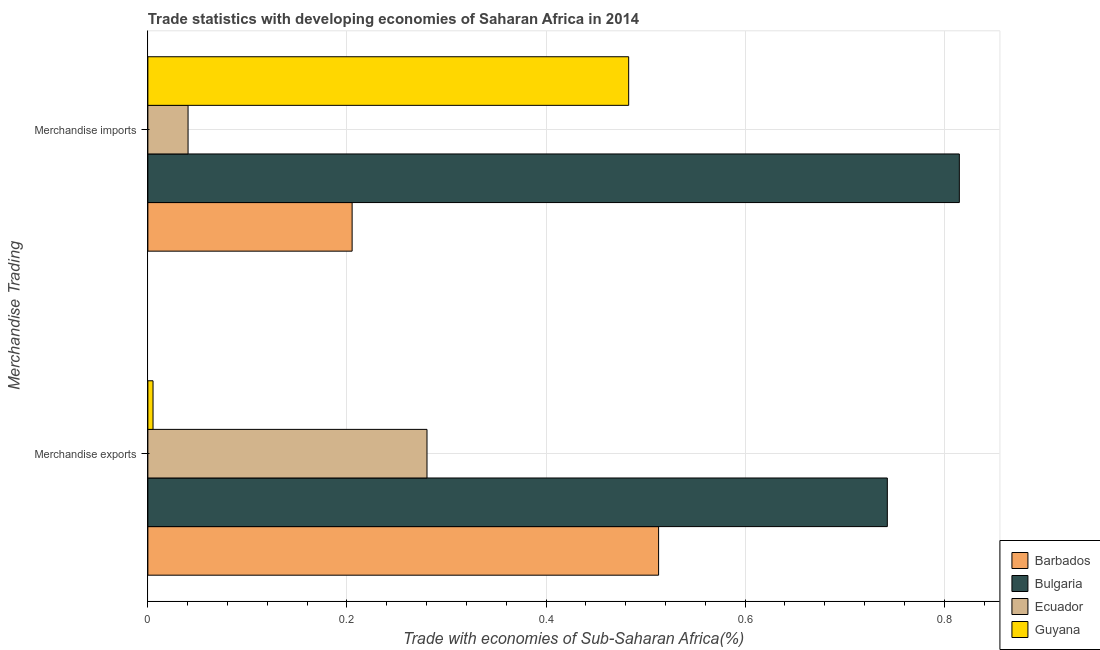What is the merchandise imports in Barbados?
Keep it short and to the point. 0.21. Across all countries, what is the maximum merchandise exports?
Your answer should be very brief. 0.74. Across all countries, what is the minimum merchandise exports?
Provide a succinct answer. 0.01. In which country was the merchandise imports maximum?
Offer a terse response. Bulgaria. In which country was the merchandise imports minimum?
Make the answer very short. Ecuador. What is the total merchandise imports in the graph?
Provide a succinct answer. 1.54. What is the difference between the merchandise exports in Barbados and that in Ecuador?
Provide a succinct answer. 0.23. What is the difference between the merchandise exports in Ecuador and the merchandise imports in Guyana?
Provide a succinct answer. -0.2. What is the average merchandise imports per country?
Keep it short and to the point. 0.39. What is the difference between the merchandise imports and merchandise exports in Ecuador?
Provide a succinct answer. -0.24. In how many countries, is the merchandise imports greater than 0.24000000000000002 %?
Your response must be concise. 2. What is the ratio of the merchandise exports in Barbados to that in Bulgaria?
Provide a short and direct response. 0.69. What does the 1st bar from the bottom in Merchandise imports represents?
Offer a terse response. Barbados. Are all the bars in the graph horizontal?
Offer a very short reply. Yes. Does the graph contain any zero values?
Provide a short and direct response. No. Does the graph contain grids?
Provide a short and direct response. Yes. Where does the legend appear in the graph?
Make the answer very short. Bottom right. How are the legend labels stacked?
Your answer should be compact. Vertical. What is the title of the graph?
Make the answer very short. Trade statistics with developing economies of Saharan Africa in 2014. What is the label or title of the X-axis?
Your answer should be very brief. Trade with economies of Sub-Saharan Africa(%). What is the label or title of the Y-axis?
Offer a very short reply. Merchandise Trading. What is the Trade with economies of Sub-Saharan Africa(%) in Barbados in Merchandise exports?
Provide a succinct answer. 0.51. What is the Trade with economies of Sub-Saharan Africa(%) in Bulgaria in Merchandise exports?
Your response must be concise. 0.74. What is the Trade with economies of Sub-Saharan Africa(%) of Ecuador in Merchandise exports?
Provide a short and direct response. 0.28. What is the Trade with economies of Sub-Saharan Africa(%) in Guyana in Merchandise exports?
Your answer should be very brief. 0.01. What is the Trade with economies of Sub-Saharan Africa(%) in Barbados in Merchandise imports?
Provide a succinct answer. 0.21. What is the Trade with economies of Sub-Saharan Africa(%) of Bulgaria in Merchandise imports?
Provide a succinct answer. 0.82. What is the Trade with economies of Sub-Saharan Africa(%) in Ecuador in Merchandise imports?
Make the answer very short. 0.04. What is the Trade with economies of Sub-Saharan Africa(%) of Guyana in Merchandise imports?
Give a very brief answer. 0.48. Across all Merchandise Trading, what is the maximum Trade with economies of Sub-Saharan Africa(%) of Barbados?
Offer a terse response. 0.51. Across all Merchandise Trading, what is the maximum Trade with economies of Sub-Saharan Africa(%) of Bulgaria?
Your answer should be very brief. 0.82. Across all Merchandise Trading, what is the maximum Trade with economies of Sub-Saharan Africa(%) of Ecuador?
Provide a short and direct response. 0.28. Across all Merchandise Trading, what is the maximum Trade with economies of Sub-Saharan Africa(%) of Guyana?
Your answer should be compact. 0.48. Across all Merchandise Trading, what is the minimum Trade with economies of Sub-Saharan Africa(%) in Barbados?
Ensure brevity in your answer.  0.21. Across all Merchandise Trading, what is the minimum Trade with economies of Sub-Saharan Africa(%) of Bulgaria?
Give a very brief answer. 0.74. Across all Merchandise Trading, what is the minimum Trade with economies of Sub-Saharan Africa(%) in Ecuador?
Provide a succinct answer. 0.04. Across all Merchandise Trading, what is the minimum Trade with economies of Sub-Saharan Africa(%) in Guyana?
Offer a very short reply. 0.01. What is the total Trade with economies of Sub-Saharan Africa(%) in Barbados in the graph?
Offer a terse response. 0.72. What is the total Trade with economies of Sub-Saharan Africa(%) in Bulgaria in the graph?
Your response must be concise. 1.56. What is the total Trade with economies of Sub-Saharan Africa(%) in Ecuador in the graph?
Provide a succinct answer. 0.32. What is the total Trade with economies of Sub-Saharan Africa(%) of Guyana in the graph?
Provide a succinct answer. 0.49. What is the difference between the Trade with economies of Sub-Saharan Africa(%) of Barbados in Merchandise exports and that in Merchandise imports?
Your response must be concise. 0.31. What is the difference between the Trade with economies of Sub-Saharan Africa(%) in Bulgaria in Merchandise exports and that in Merchandise imports?
Offer a very short reply. -0.07. What is the difference between the Trade with economies of Sub-Saharan Africa(%) in Ecuador in Merchandise exports and that in Merchandise imports?
Provide a succinct answer. 0.24. What is the difference between the Trade with economies of Sub-Saharan Africa(%) in Guyana in Merchandise exports and that in Merchandise imports?
Provide a short and direct response. -0.48. What is the difference between the Trade with economies of Sub-Saharan Africa(%) in Barbados in Merchandise exports and the Trade with economies of Sub-Saharan Africa(%) in Bulgaria in Merchandise imports?
Your answer should be very brief. -0.3. What is the difference between the Trade with economies of Sub-Saharan Africa(%) of Barbados in Merchandise exports and the Trade with economies of Sub-Saharan Africa(%) of Ecuador in Merchandise imports?
Provide a short and direct response. 0.47. What is the difference between the Trade with economies of Sub-Saharan Africa(%) in Barbados in Merchandise exports and the Trade with economies of Sub-Saharan Africa(%) in Guyana in Merchandise imports?
Provide a succinct answer. 0.03. What is the difference between the Trade with economies of Sub-Saharan Africa(%) in Bulgaria in Merchandise exports and the Trade with economies of Sub-Saharan Africa(%) in Ecuador in Merchandise imports?
Provide a short and direct response. 0.7. What is the difference between the Trade with economies of Sub-Saharan Africa(%) of Bulgaria in Merchandise exports and the Trade with economies of Sub-Saharan Africa(%) of Guyana in Merchandise imports?
Offer a terse response. 0.26. What is the difference between the Trade with economies of Sub-Saharan Africa(%) in Ecuador in Merchandise exports and the Trade with economies of Sub-Saharan Africa(%) in Guyana in Merchandise imports?
Your answer should be compact. -0.2. What is the average Trade with economies of Sub-Saharan Africa(%) in Barbados per Merchandise Trading?
Keep it short and to the point. 0.36. What is the average Trade with economies of Sub-Saharan Africa(%) of Bulgaria per Merchandise Trading?
Your answer should be compact. 0.78. What is the average Trade with economies of Sub-Saharan Africa(%) in Ecuador per Merchandise Trading?
Offer a terse response. 0.16. What is the average Trade with economies of Sub-Saharan Africa(%) in Guyana per Merchandise Trading?
Ensure brevity in your answer.  0.24. What is the difference between the Trade with economies of Sub-Saharan Africa(%) in Barbados and Trade with economies of Sub-Saharan Africa(%) in Bulgaria in Merchandise exports?
Offer a very short reply. -0.23. What is the difference between the Trade with economies of Sub-Saharan Africa(%) of Barbados and Trade with economies of Sub-Saharan Africa(%) of Ecuador in Merchandise exports?
Provide a succinct answer. 0.23. What is the difference between the Trade with economies of Sub-Saharan Africa(%) of Barbados and Trade with economies of Sub-Saharan Africa(%) of Guyana in Merchandise exports?
Ensure brevity in your answer.  0.51. What is the difference between the Trade with economies of Sub-Saharan Africa(%) in Bulgaria and Trade with economies of Sub-Saharan Africa(%) in Ecuador in Merchandise exports?
Your answer should be very brief. 0.46. What is the difference between the Trade with economies of Sub-Saharan Africa(%) of Bulgaria and Trade with economies of Sub-Saharan Africa(%) of Guyana in Merchandise exports?
Provide a succinct answer. 0.74. What is the difference between the Trade with economies of Sub-Saharan Africa(%) in Ecuador and Trade with economies of Sub-Saharan Africa(%) in Guyana in Merchandise exports?
Offer a very short reply. 0.28. What is the difference between the Trade with economies of Sub-Saharan Africa(%) in Barbados and Trade with economies of Sub-Saharan Africa(%) in Bulgaria in Merchandise imports?
Give a very brief answer. -0.61. What is the difference between the Trade with economies of Sub-Saharan Africa(%) in Barbados and Trade with economies of Sub-Saharan Africa(%) in Ecuador in Merchandise imports?
Ensure brevity in your answer.  0.16. What is the difference between the Trade with economies of Sub-Saharan Africa(%) in Barbados and Trade with economies of Sub-Saharan Africa(%) in Guyana in Merchandise imports?
Offer a very short reply. -0.28. What is the difference between the Trade with economies of Sub-Saharan Africa(%) of Bulgaria and Trade with economies of Sub-Saharan Africa(%) of Ecuador in Merchandise imports?
Provide a succinct answer. 0.77. What is the difference between the Trade with economies of Sub-Saharan Africa(%) in Bulgaria and Trade with economies of Sub-Saharan Africa(%) in Guyana in Merchandise imports?
Offer a terse response. 0.33. What is the difference between the Trade with economies of Sub-Saharan Africa(%) in Ecuador and Trade with economies of Sub-Saharan Africa(%) in Guyana in Merchandise imports?
Offer a terse response. -0.44. What is the ratio of the Trade with economies of Sub-Saharan Africa(%) in Barbados in Merchandise exports to that in Merchandise imports?
Provide a short and direct response. 2.5. What is the ratio of the Trade with economies of Sub-Saharan Africa(%) of Bulgaria in Merchandise exports to that in Merchandise imports?
Your response must be concise. 0.91. What is the ratio of the Trade with economies of Sub-Saharan Africa(%) in Ecuador in Merchandise exports to that in Merchandise imports?
Give a very brief answer. 6.94. What is the ratio of the Trade with economies of Sub-Saharan Africa(%) of Guyana in Merchandise exports to that in Merchandise imports?
Offer a terse response. 0.01. What is the difference between the highest and the second highest Trade with economies of Sub-Saharan Africa(%) in Barbados?
Offer a terse response. 0.31. What is the difference between the highest and the second highest Trade with economies of Sub-Saharan Africa(%) in Bulgaria?
Offer a terse response. 0.07. What is the difference between the highest and the second highest Trade with economies of Sub-Saharan Africa(%) in Ecuador?
Offer a terse response. 0.24. What is the difference between the highest and the second highest Trade with economies of Sub-Saharan Africa(%) of Guyana?
Your answer should be very brief. 0.48. What is the difference between the highest and the lowest Trade with economies of Sub-Saharan Africa(%) in Barbados?
Provide a succinct answer. 0.31. What is the difference between the highest and the lowest Trade with economies of Sub-Saharan Africa(%) of Bulgaria?
Offer a very short reply. 0.07. What is the difference between the highest and the lowest Trade with economies of Sub-Saharan Africa(%) of Ecuador?
Provide a short and direct response. 0.24. What is the difference between the highest and the lowest Trade with economies of Sub-Saharan Africa(%) in Guyana?
Keep it short and to the point. 0.48. 